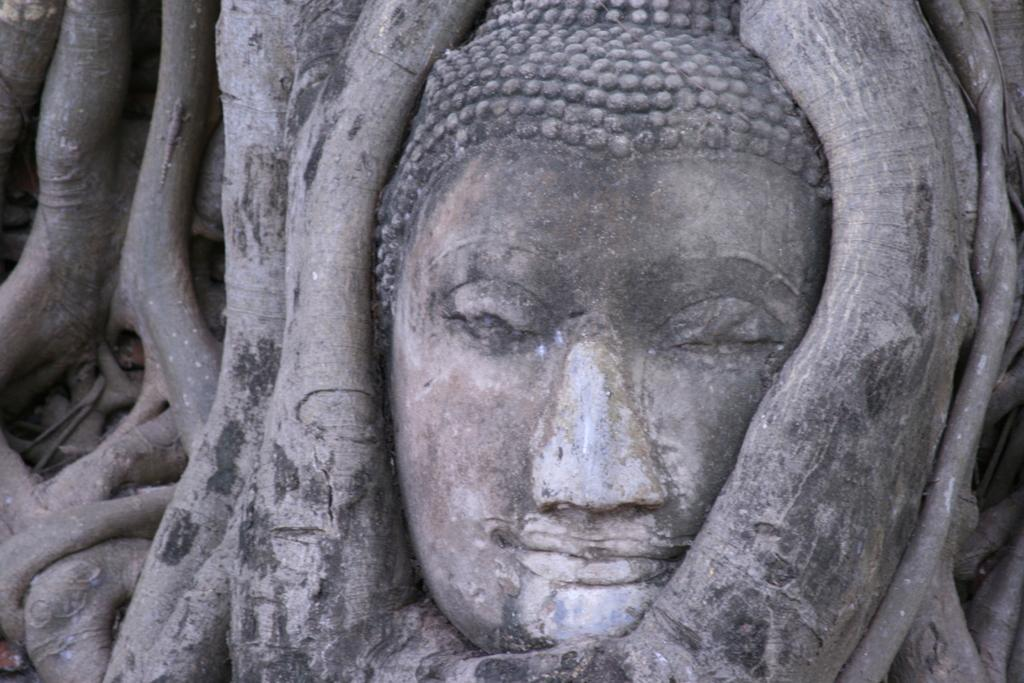What is the main subject of the image? The main subject of the image is a sculpture. Where is the sculpture located? The sculpture is in a tree. Is there a bathtub visible in the image? No, there is no bathtub present in the image. 